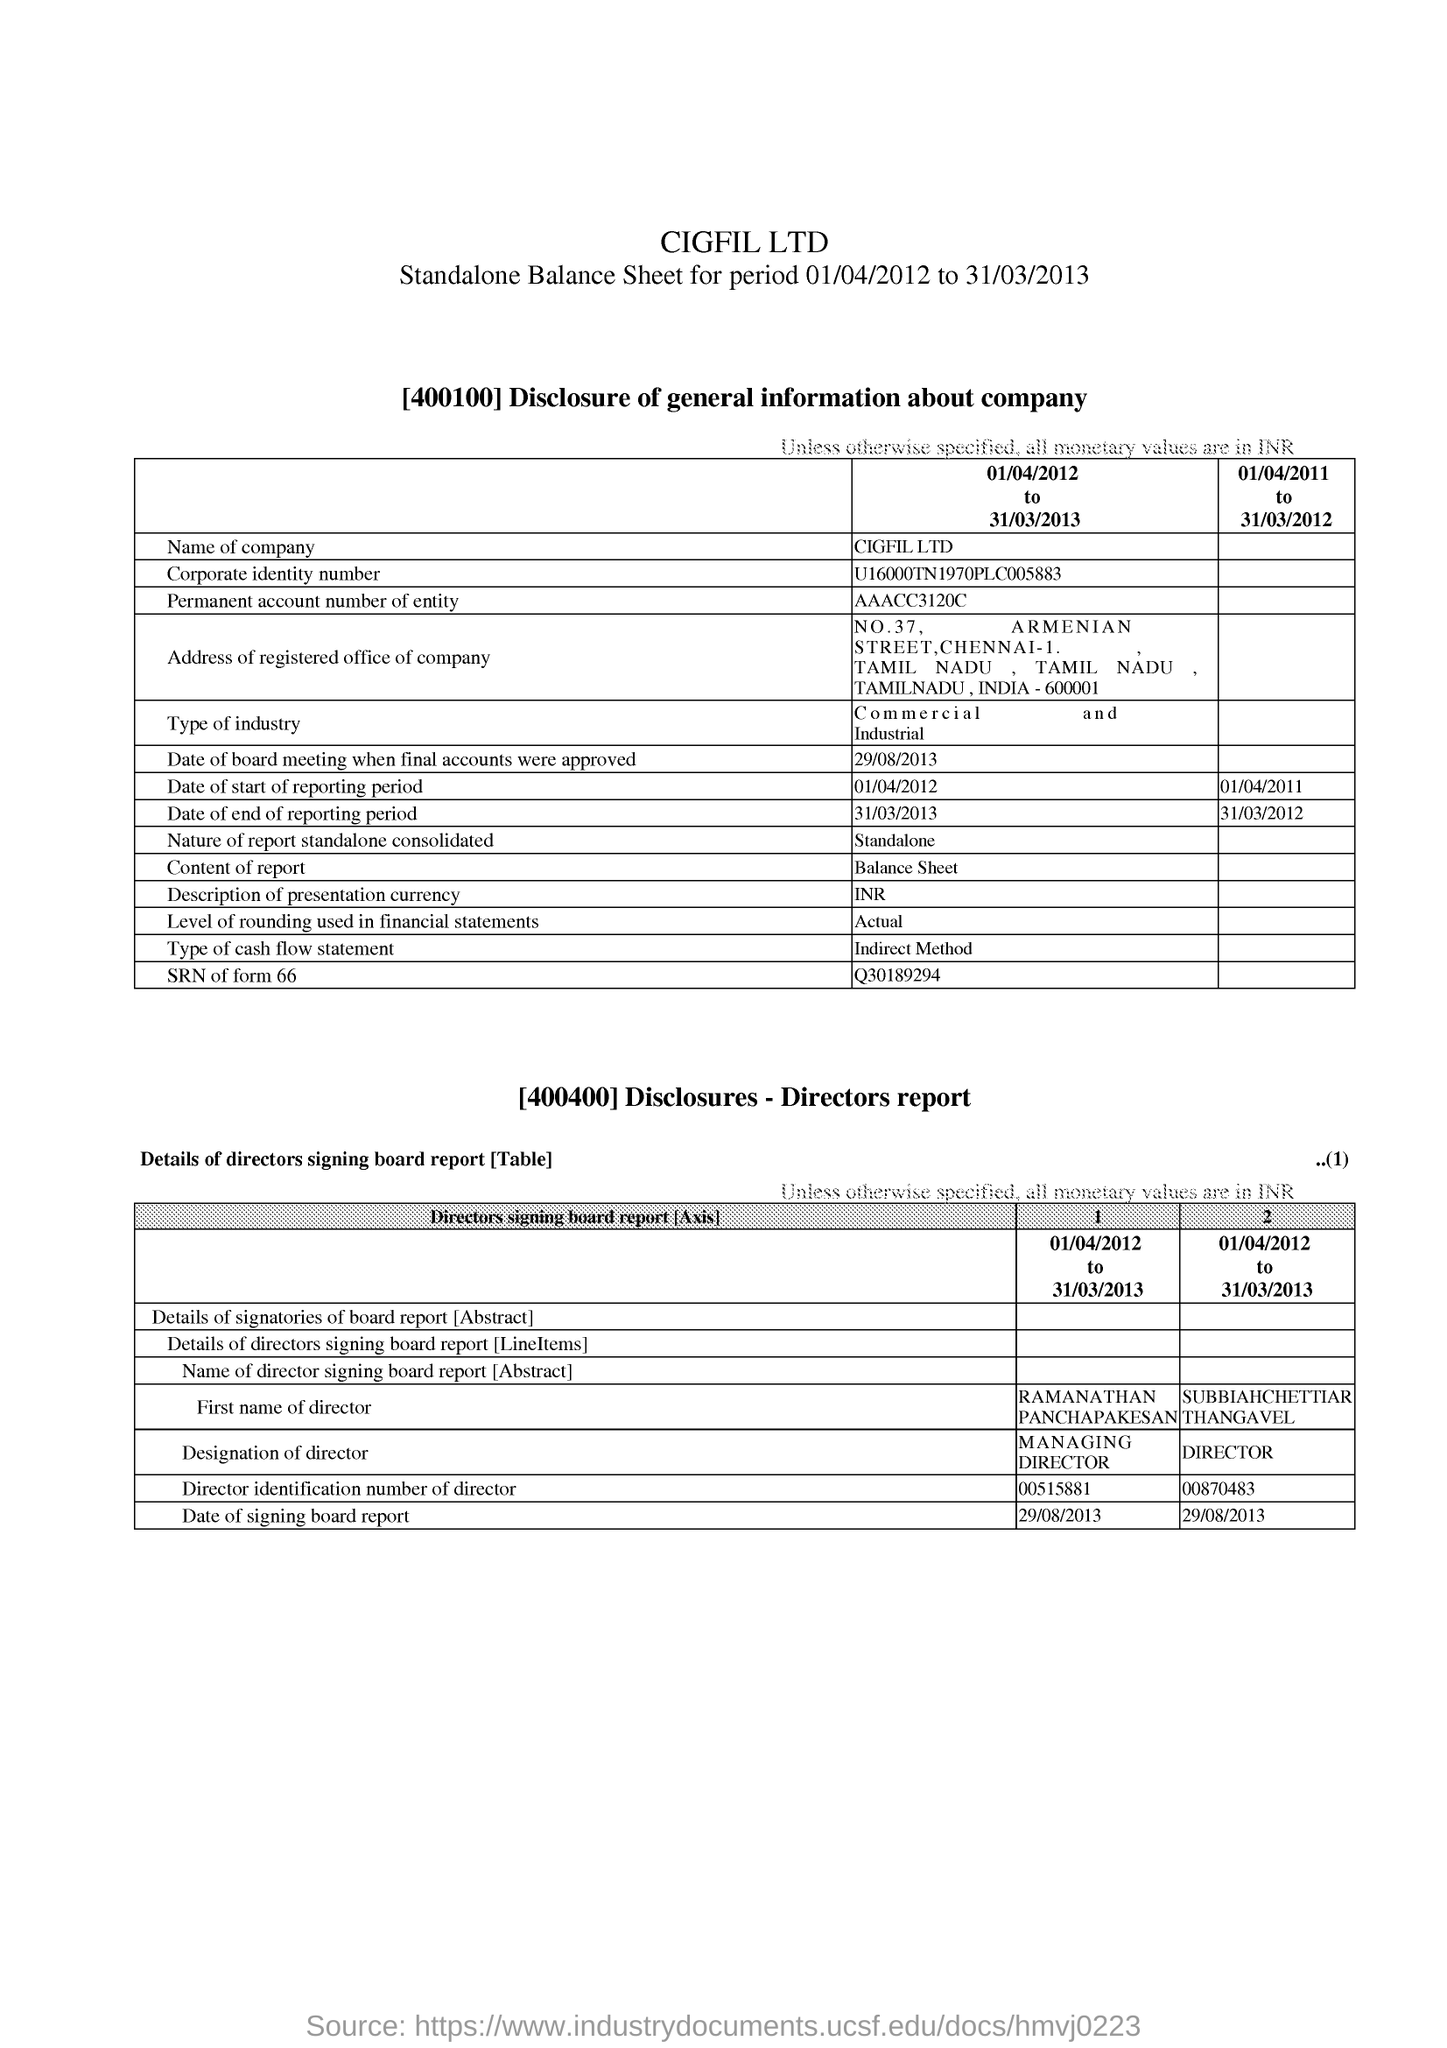Specify some key components in this picture. The permanent account number of the entity is AAACC3120C.. The company named CIGFIL LTD. is the correct name of the company. The date of the signing board report is August 29, 2013. 